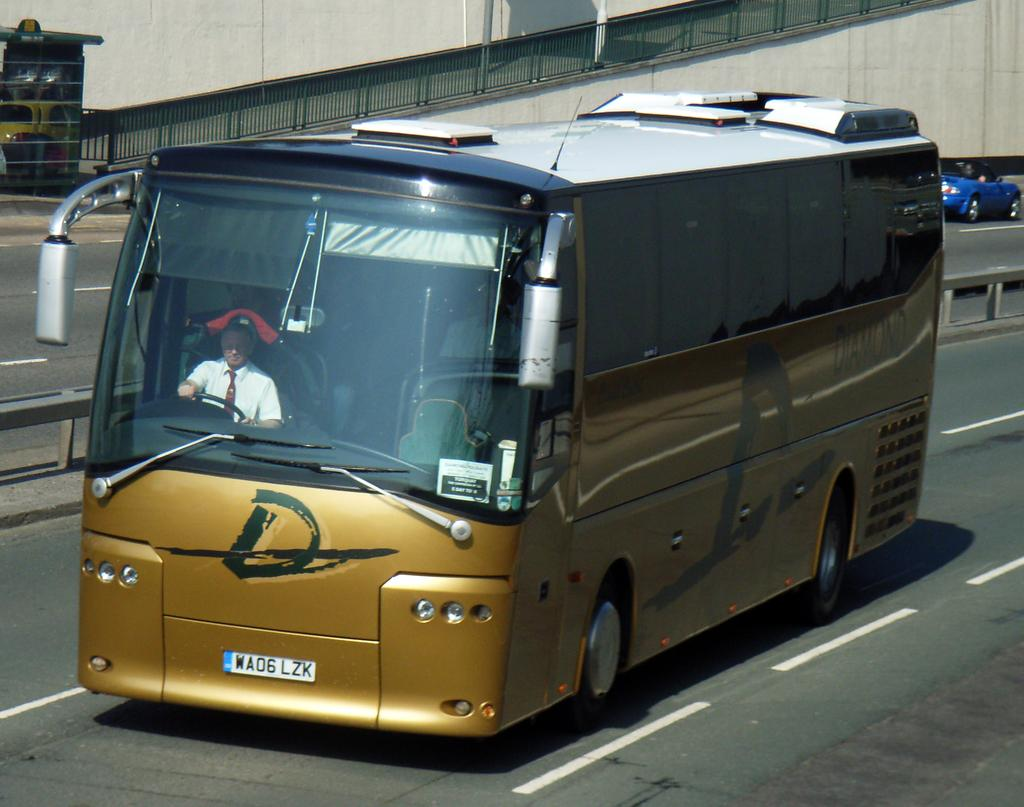What is the person in the image doing? The person is driving a bus in the image. How is the person dressed while driving the bus? The person is wearing a white shirt and a tie. What other vehicle can be seen in the image? There is a blue car in the image. What can be seen near the bus in the image? There is railing in the image. What is visible in the background of the image? There is a building in the background of the image. What type of decision-making guide is the person holding while driving the bus? There is no decision-making guide present in the image; the person is simply driving the bus. What type of plate is visible on the bus in the image? There is no plate visible on the bus in the image. 